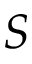Convert formula to latex. <formula><loc_0><loc_0><loc_500><loc_500>S</formula> 